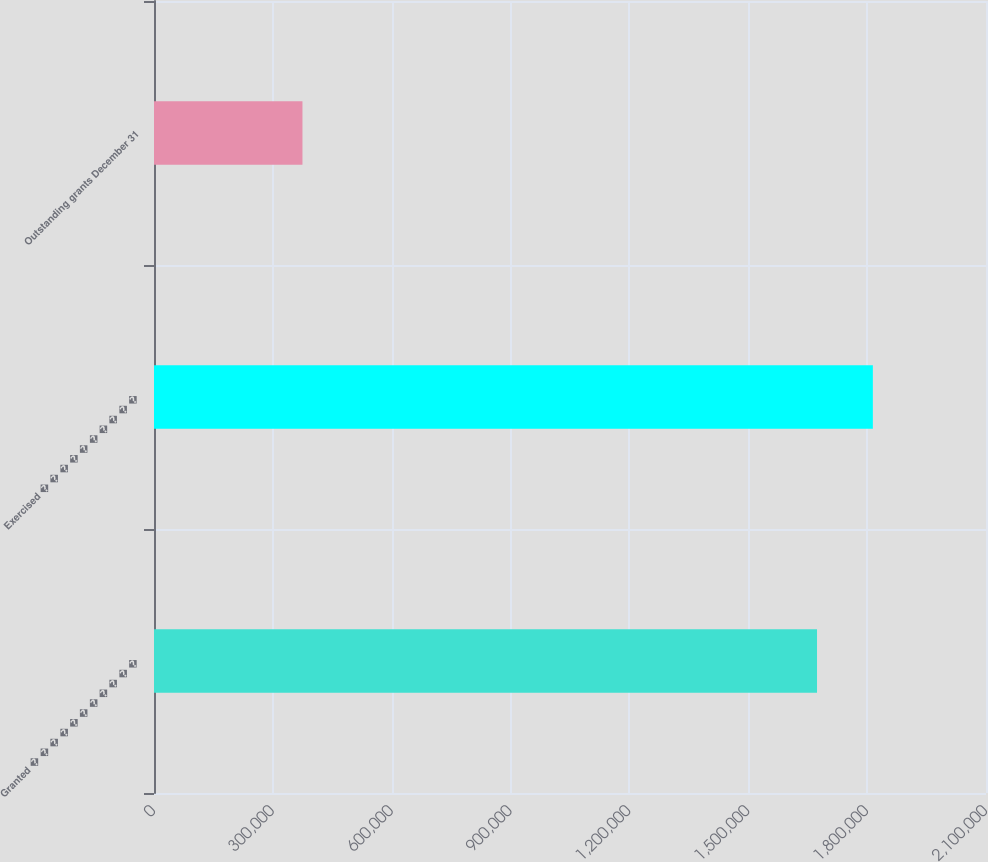Convert chart to OTSL. <chart><loc_0><loc_0><loc_500><loc_500><bar_chart><fcel>Granted � � � � � � � � � � �<fcel>Exercised � � � � � � � � � �<fcel>Outstanding grants December 31<nl><fcel>1.67348e+06<fcel>1.81443e+06<fcel>374703<nl></chart> 